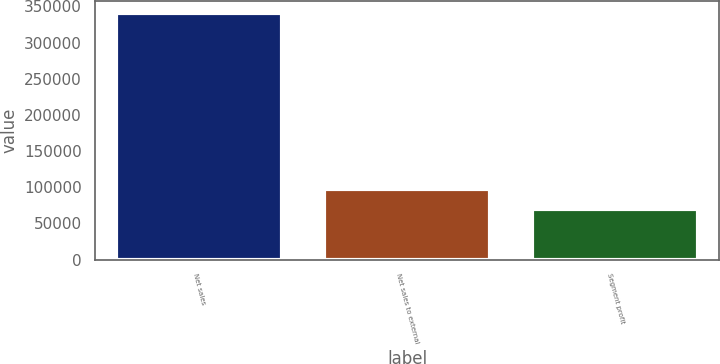<chart> <loc_0><loc_0><loc_500><loc_500><bar_chart><fcel>Net sales<fcel>Net sales to external<fcel>Segment profit<nl><fcel>340849<fcel>97159.6<fcel>70083<nl></chart> 